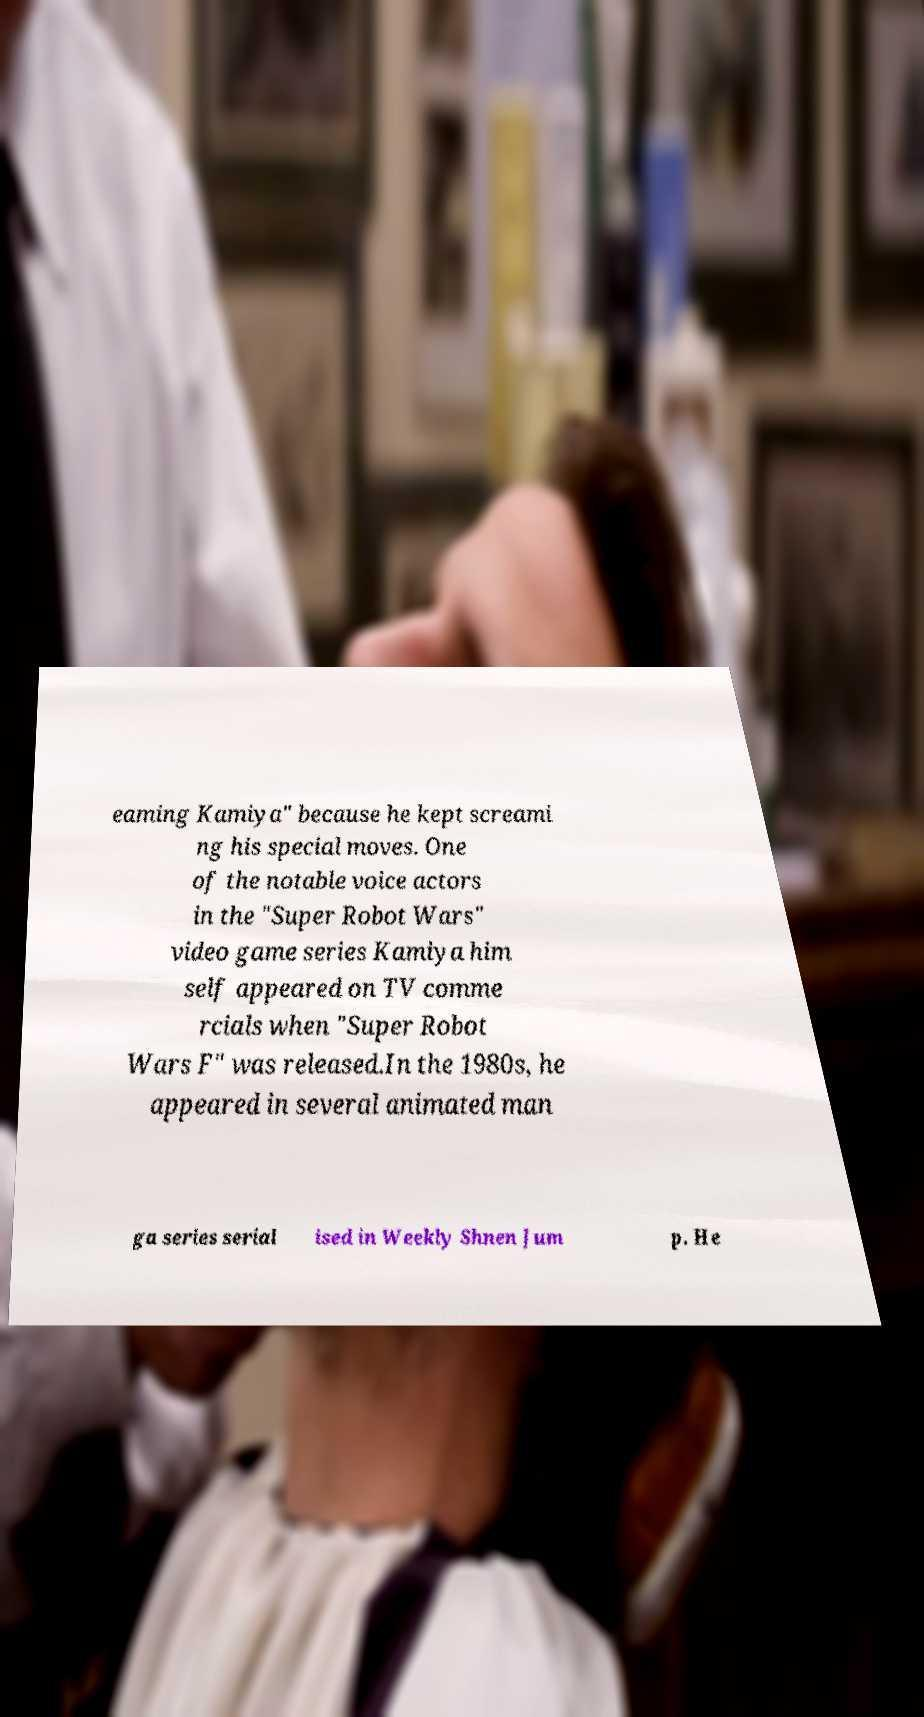Can you read and provide the text displayed in the image?This photo seems to have some interesting text. Can you extract and type it out for me? eaming Kamiya" because he kept screami ng his special moves. One of the notable voice actors in the "Super Robot Wars" video game series Kamiya him self appeared on TV comme rcials when "Super Robot Wars F" was released.In the 1980s, he appeared in several animated man ga series serial ised in Weekly Shnen Jum p. He 